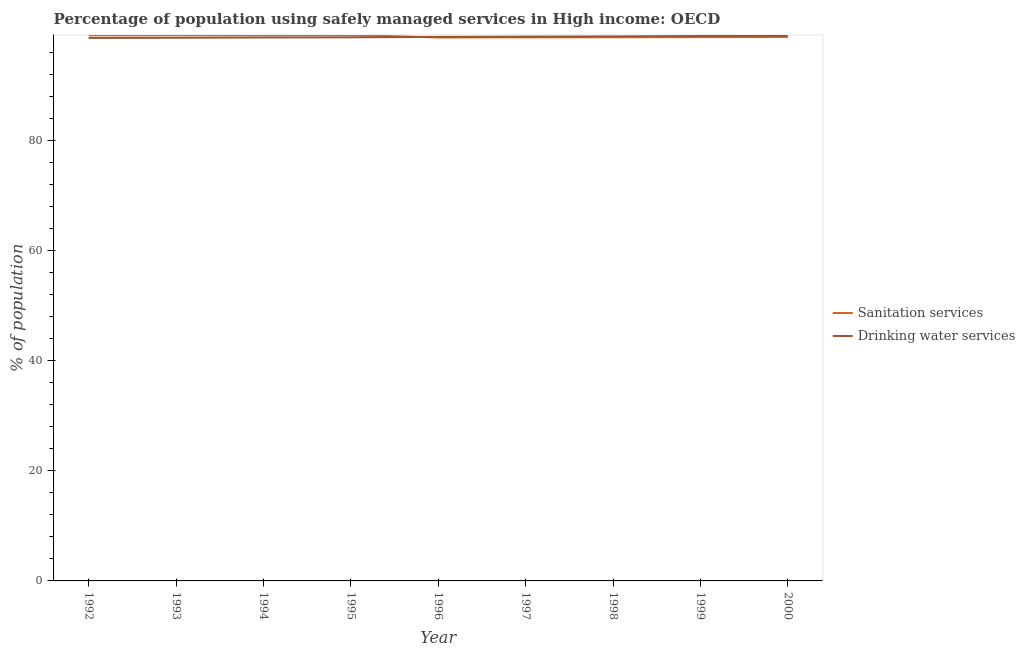How many different coloured lines are there?
Make the answer very short. 2. Is the number of lines equal to the number of legend labels?
Offer a terse response. Yes. What is the percentage of population who used sanitation services in 1993?
Offer a very short reply. 99.13. Across all years, what is the maximum percentage of population who used sanitation services?
Ensure brevity in your answer.  99.17. Across all years, what is the minimum percentage of population who used drinking water services?
Offer a very short reply. 98.64. In which year was the percentage of population who used sanitation services maximum?
Provide a succinct answer. 1995. In which year was the percentage of population who used drinking water services minimum?
Give a very brief answer. 1992. What is the total percentage of population who used sanitation services in the graph?
Keep it short and to the point. 890.37. What is the difference between the percentage of population who used sanitation services in 1994 and that in 2000?
Your answer should be compact. 0.34. What is the difference between the percentage of population who used drinking water services in 1999 and the percentage of population who used sanitation services in 1994?
Offer a terse response. -0.16. What is the average percentage of population who used drinking water services per year?
Provide a short and direct response. 98.82. In the year 1999, what is the difference between the percentage of population who used sanitation services and percentage of population who used drinking water services?
Ensure brevity in your answer.  -0.21. What is the ratio of the percentage of population who used sanitation services in 1998 to that in 1999?
Provide a short and direct response. 1. Is the percentage of population who used drinking water services in 1996 less than that in 1997?
Provide a short and direct response. Yes. What is the difference between the highest and the second highest percentage of population who used drinking water services?
Keep it short and to the point. 0.04. What is the difference between the highest and the lowest percentage of population who used drinking water services?
Give a very brief answer. 0.39. In how many years, is the percentage of population who used drinking water services greater than the average percentage of population who used drinking water services taken over all years?
Provide a short and direct response. 5. Are the values on the major ticks of Y-axis written in scientific E-notation?
Offer a terse response. No. Does the graph contain grids?
Give a very brief answer. No. Where does the legend appear in the graph?
Offer a very short reply. Center right. How many legend labels are there?
Offer a very short reply. 2. What is the title of the graph?
Your answer should be very brief. Percentage of population using safely managed services in High income: OECD. Does "Personal remittances" appear as one of the legend labels in the graph?
Provide a succinct answer. No. What is the label or title of the Y-axis?
Provide a short and direct response. % of population. What is the % of population of Sanitation services in 1992?
Offer a terse response. 99.11. What is the % of population in Drinking water services in 1992?
Offer a terse response. 98.64. What is the % of population of Sanitation services in 1993?
Offer a terse response. 99.13. What is the % of population of Drinking water services in 1993?
Your answer should be very brief. 98.67. What is the % of population in Sanitation services in 1994?
Provide a short and direct response. 99.15. What is the % of population of Drinking water services in 1994?
Your answer should be very brief. 98.72. What is the % of population of Sanitation services in 1995?
Keep it short and to the point. 99.17. What is the % of population in Drinking water services in 1995?
Your answer should be compact. 98.75. What is the % of population in Sanitation services in 1996?
Your answer should be very brief. 98.72. What is the % of population in Drinking water services in 1996?
Ensure brevity in your answer.  98.82. What is the % of population in Sanitation services in 1997?
Your response must be concise. 98.74. What is the % of population in Drinking water services in 1997?
Make the answer very short. 98.87. What is the % of population in Sanitation services in 1998?
Your answer should be compact. 98.76. What is the % of population in Drinking water services in 1998?
Your answer should be very brief. 98.91. What is the % of population in Sanitation services in 1999?
Offer a very short reply. 98.78. What is the % of population of Drinking water services in 1999?
Provide a short and direct response. 98.99. What is the % of population in Sanitation services in 2000?
Make the answer very short. 98.8. What is the % of population in Drinking water services in 2000?
Provide a succinct answer. 99.02. Across all years, what is the maximum % of population in Sanitation services?
Offer a terse response. 99.17. Across all years, what is the maximum % of population of Drinking water services?
Offer a very short reply. 99.02. Across all years, what is the minimum % of population of Sanitation services?
Provide a short and direct response. 98.72. Across all years, what is the minimum % of population in Drinking water services?
Ensure brevity in your answer.  98.64. What is the total % of population of Sanitation services in the graph?
Ensure brevity in your answer.  890.37. What is the total % of population of Drinking water services in the graph?
Keep it short and to the point. 889.4. What is the difference between the % of population of Sanitation services in 1992 and that in 1993?
Give a very brief answer. -0.02. What is the difference between the % of population in Drinking water services in 1992 and that in 1993?
Offer a terse response. -0.03. What is the difference between the % of population of Sanitation services in 1992 and that in 1994?
Give a very brief answer. -0.04. What is the difference between the % of population of Drinking water services in 1992 and that in 1994?
Offer a very short reply. -0.09. What is the difference between the % of population in Sanitation services in 1992 and that in 1995?
Offer a very short reply. -0.05. What is the difference between the % of population of Drinking water services in 1992 and that in 1995?
Make the answer very short. -0.11. What is the difference between the % of population of Sanitation services in 1992 and that in 1996?
Offer a very short reply. 0.39. What is the difference between the % of population of Drinking water services in 1992 and that in 1996?
Give a very brief answer. -0.19. What is the difference between the % of population of Sanitation services in 1992 and that in 1997?
Your answer should be very brief. 0.37. What is the difference between the % of population of Drinking water services in 1992 and that in 1997?
Give a very brief answer. -0.23. What is the difference between the % of population in Sanitation services in 1992 and that in 1998?
Offer a terse response. 0.35. What is the difference between the % of population in Drinking water services in 1992 and that in 1998?
Make the answer very short. -0.27. What is the difference between the % of population in Sanitation services in 1992 and that in 1999?
Provide a succinct answer. 0.34. What is the difference between the % of population in Drinking water services in 1992 and that in 1999?
Give a very brief answer. -0.35. What is the difference between the % of population of Sanitation services in 1992 and that in 2000?
Your response must be concise. 0.31. What is the difference between the % of population of Drinking water services in 1992 and that in 2000?
Keep it short and to the point. -0.39. What is the difference between the % of population in Sanitation services in 1993 and that in 1994?
Your answer should be very brief. -0.02. What is the difference between the % of population in Drinking water services in 1993 and that in 1994?
Keep it short and to the point. -0.06. What is the difference between the % of population in Sanitation services in 1993 and that in 1995?
Offer a terse response. -0.03. What is the difference between the % of population of Drinking water services in 1993 and that in 1995?
Keep it short and to the point. -0.08. What is the difference between the % of population in Sanitation services in 1993 and that in 1996?
Your answer should be very brief. 0.41. What is the difference between the % of population of Drinking water services in 1993 and that in 1996?
Your answer should be compact. -0.15. What is the difference between the % of population in Sanitation services in 1993 and that in 1997?
Ensure brevity in your answer.  0.39. What is the difference between the % of population in Drinking water services in 1993 and that in 1997?
Provide a succinct answer. -0.2. What is the difference between the % of population in Sanitation services in 1993 and that in 1998?
Provide a succinct answer. 0.37. What is the difference between the % of population in Drinking water services in 1993 and that in 1998?
Offer a terse response. -0.24. What is the difference between the % of population in Sanitation services in 1993 and that in 1999?
Your answer should be compact. 0.35. What is the difference between the % of population in Drinking water services in 1993 and that in 1999?
Give a very brief answer. -0.32. What is the difference between the % of population of Sanitation services in 1993 and that in 2000?
Provide a short and direct response. 0.33. What is the difference between the % of population in Drinking water services in 1993 and that in 2000?
Provide a short and direct response. -0.36. What is the difference between the % of population of Sanitation services in 1994 and that in 1995?
Your response must be concise. -0.02. What is the difference between the % of population of Drinking water services in 1994 and that in 1995?
Give a very brief answer. -0.03. What is the difference between the % of population of Sanitation services in 1994 and that in 1996?
Make the answer very short. 0.43. What is the difference between the % of population of Drinking water services in 1994 and that in 1996?
Ensure brevity in your answer.  -0.1. What is the difference between the % of population of Sanitation services in 1994 and that in 1997?
Ensure brevity in your answer.  0.41. What is the difference between the % of population of Drinking water services in 1994 and that in 1997?
Your response must be concise. -0.14. What is the difference between the % of population in Sanitation services in 1994 and that in 1998?
Offer a very short reply. 0.39. What is the difference between the % of population of Drinking water services in 1994 and that in 1998?
Provide a succinct answer. -0.19. What is the difference between the % of population of Sanitation services in 1994 and that in 1999?
Ensure brevity in your answer.  0.37. What is the difference between the % of population in Drinking water services in 1994 and that in 1999?
Make the answer very short. -0.26. What is the difference between the % of population in Sanitation services in 1994 and that in 2000?
Ensure brevity in your answer.  0.34. What is the difference between the % of population in Sanitation services in 1995 and that in 1996?
Your response must be concise. 0.44. What is the difference between the % of population of Drinking water services in 1995 and that in 1996?
Your answer should be compact. -0.07. What is the difference between the % of population in Sanitation services in 1995 and that in 1997?
Make the answer very short. 0.42. What is the difference between the % of population in Drinking water services in 1995 and that in 1997?
Give a very brief answer. -0.12. What is the difference between the % of population of Sanitation services in 1995 and that in 1998?
Offer a very short reply. 0.41. What is the difference between the % of population of Drinking water services in 1995 and that in 1998?
Your response must be concise. -0.16. What is the difference between the % of population of Sanitation services in 1995 and that in 1999?
Provide a succinct answer. 0.39. What is the difference between the % of population of Drinking water services in 1995 and that in 1999?
Your answer should be very brief. -0.24. What is the difference between the % of population of Sanitation services in 1995 and that in 2000?
Make the answer very short. 0.36. What is the difference between the % of population of Drinking water services in 1995 and that in 2000?
Your answer should be compact. -0.27. What is the difference between the % of population of Sanitation services in 1996 and that in 1997?
Offer a terse response. -0.02. What is the difference between the % of population of Drinking water services in 1996 and that in 1997?
Offer a terse response. -0.05. What is the difference between the % of population of Sanitation services in 1996 and that in 1998?
Keep it short and to the point. -0.04. What is the difference between the % of population in Drinking water services in 1996 and that in 1998?
Provide a succinct answer. -0.09. What is the difference between the % of population of Sanitation services in 1996 and that in 1999?
Ensure brevity in your answer.  -0.06. What is the difference between the % of population in Drinking water services in 1996 and that in 1999?
Your answer should be very brief. -0.16. What is the difference between the % of population of Sanitation services in 1996 and that in 2000?
Keep it short and to the point. -0.08. What is the difference between the % of population of Drinking water services in 1996 and that in 2000?
Provide a short and direct response. -0.2. What is the difference between the % of population in Sanitation services in 1997 and that in 1998?
Your answer should be very brief. -0.02. What is the difference between the % of population of Drinking water services in 1997 and that in 1998?
Your answer should be compact. -0.04. What is the difference between the % of population in Sanitation services in 1997 and that in 1999?
Give a very brief answer. -0.04. What is the difference between the % of population of Drinking water services in 1997 and that in 1999?
Provide a succinct answer. -0.12. What is the difference between the % of population of Sanitation services in 1997 and that in 2000?
Provide a succinct answer. -0.06. What is the difference between the % of population in Drinking water services in 1997 and that in 2000?
Give a very brief answer. -0.16. What is the difference between the % of population in Sanitation services in 1998 and that in 1999?
Provide a short and direct response. -0.02. What is the difference between the % of population in Drinking water services in 1998 and that in 1999?
Your response must be concise. -0.08. What is the difference between the % of population of Sanitation services in 1998 and that in 2000?
Offer a very short reply. -0.04. What is the difference between the % of population in Drinking water services in 1998 and that in 2000?
Your answer should be compact. -0.11. What is the difference between the % of population of Sanitation services in 1999 and that in 2000?
Give a very brief answer. -0.03. What is the difference between the % of population of Drinking water services in 1999 and that in 2000?
Make the answer very short. -0.04. What is the difference between the % of population in Sanitation services in 1992 and the % of population in Drinking water services in 1993?
Make the answer very short. 0.45. What is the difference between the % of population of Sanitation services in 1992 and the % of population of Drinking water services in 1994?
Offer a terse response. 0.39. What is the difference between the % of population of Sanitation services in 1992 and the % of population of Drinking water services in 1995?
Provide a succinct answer. 0.36. What is the difference between the % of population in Sanitation services in 1992 and the % of population in Drinking water services in 1996?
Offer a terse response. 0.29. What is the difference between the % of population in Sanitation services in 1992 and the % of population in Drinking water services in 1997?
Make the answer very short. 0.25. What is the difference between the % of population in Sanitation services in 1992 and the % of population in Drinking water services in 1998?
Offer a very short reply. 0.2. What is the difference between the % of population of Sanitation services in 1992 and the % of population of Drinking water services in 1999?
Make the answer very short. 0.13. What is the difference between the % of population of Sanitation services in 1992 and the % of population of Drinking water services in 2000?
Your answer should be very brief. 0.09. What is the difference between the % of population of Sanitation services in 1993 and the % of population of Drinking water services in 1994?
Your response must be concise. 0.41. What is the difference between the % of population in Sanitation services in 1993 and the % of population in Drinking water services in 1995?
Provide a succinct answer. 0.38. What is the difference between the % of population of Sanitation services in 1993 and the % of population of Drinking water services in 1996?
Your answer should be compact. 0.31. What is the difference between the % of population of Sanitation services in 1993 and the % of population of Drinking water services in 1997?
Keep it short and to the point. 0.26. What is the difference between the % of population in Sanitation services in 1993 and the % of population in Drinking water services in 1998?
Make the answer very short. 0.22. What is the difference between the % of population of Sanitation services in 1993 and the % of population of Drinking water services in 1999?
Your response must be concise. 0.15. What is the difference between the % of population in Sanitation services in 1993 and the % of population in Drinking water services in 2000?
Make the answer very short. 0.11. What is the difference between the % of population of Sanitation services in 1994 and the % of population of Drinking water services in 1995?
Keep it short and to the point. 0.4. What is the difference between the % of population in Sanitation services in 1994 and the % of population in Drinking water services in 1996?
Your answer should be compact. 0.33. What is the difference between the % of population in Sanitation services in 1994 and the % of population in Drinking water services in 1997?
Your response must be concise. 0.28. What is the difference between the % of population in Sanitation services in 1994 and the % of population in Drinking water services in 1998?
Provide a short and direct response. 0.24. What is the difference between the % of population of Sanitation services in 1994 and the % of population of Drinking water services in 1999?
Provide a short and direct response. 0.16. What is the difference between the % of population in Sanitation services in 1994 and the % of population in Drinking water services in 2000?
Your answer should be compact. 0.13. What is the difference between the % of population of Sanitation services in 1995 and the % of population of Drinking water services in 1996?
Provide a short and direct response. 0.34. What is the difference between the % of population in Sanitation services in 1995 and the % of population in Drinking water services in 1997?
Your response must be concise. 0.3. What is the difference between the % of population in Sanitation services in 1995 and the % of population in Drinking water services in 1998?
Make the answer very short. 0.26. What is the difference between the % of population in Sanitation services in 1995 and the % of population in Drinking water services in 1999?
Your answer should be very brief. 0.18. What is the difference between the % of population in Sanitation services in 1995 and the % of population in Drinking water services in 2000?
Your answer should be compact. 0.14. What is the difference between the % of population in Sanitation services in 1996 and the % of population in Drinking water services in 1997?
Give a very brief answer. -0.15. What is the difference between the % of population in Sanitation services in 1996 and the % of population in Drinking water services in 1998?
Provide a succinct answer. -0.19. What is the difference between the % of population of Sanitation services in 1996 and the % of population of Drinking water services in 1999?
Make the answer very short. -0.26. What is the difference between the % of population in Sanitation services in 1996 and the % of population in Drinking water services in 2000?
Offer a very short reply. -0.3. What is the difference between the % of population in Sanitation services in 1997 and the % of population in Drinking water services in 1998?
Ensure brevity in your answer.  -0.17. What is the difference between the % of population in Sanitation services in 1997 and the % of population in Drinking water services in 1999?
Give a very brief answer. -0.24. What is the difference between the % of population in Sanitation services in 1997 and the % of population in Drinking water services in 2000?
Provide a short and direct response. -0.28. What is the difference between the % of population in Sanitation services in 1998 and the % of population in Drinking water services in 1999?
Make the answer very short. -0.23. What is the difference between the % of population in Sanitation services in 1998 and the % of population in Drinking water services in 2000?
Give a very brief answer. -0.26. What is the difference between the % of population of Sanitation services in 1999 and the % of population of Drinking water services in 2000?
Ensure brevity in your answer.  -0.25. What is the average % of population in Sanitation services per year?
Ensure brevity in your answer.  98.93. What is the average % of population of Drinking water services per year?
Offer a terse response. 98.82. In the year 1992, what is the difference between the % of population in Sanitation services and % of population in Drinking water services?
Offer a very short reply. 0.48. In the year 1993, what is the difference between the % of population of Sanitation services and % of population of Drinking water services?
Your answer should be very brief. 0.46. In the year 1994, what is the difference between the % of population in Sanitation services and % of population in Drinking water services?
Provide a succinct answer. 0.43. In the year 1995, what is the difference between the % of population in Sanitation services and % of population in Drinking water services?
Provide a short and direct response. 0.42. In the year 1996, what is the difference between the % of population of Sanitation services and % of population of Drinking water services?
Provide a succinct answer. -0.1. In the year 1997, what is the difference between the % of population of Sanitation services and % of population of Drinking water services?
Offer a terse response. -0.13. In the year 1998, what is the difference between the % of population in Sanitation services and % of population in Drinking water services?
Give a very brief answer. -0.15. In the year 1999, what is the difference between the % of population of Sanitation services and % of population of Drinking water services?
Make the answer very short. -0.21. In the year 2000, what is the difference between the % of population of Sanitation services and % of population of Drinking water services?
Your answer should be compact. -0.22. What is the ratio of the % of population in Drinking water services in 1992 to that in 1993?
Provide a short and direct response. 1. What is the ratio of the % of population of Drinking water services in 1992 to that in 1996?
Your response must be concise. 1. What is the ratio of the % of population of Sanitation services in 1992 to that in 1997?
Ensure brevity in your answer.  1. What is the ratio of the % of population of Sanitation services in 1992 to that in 1998?
Provide a short and direct response. 1. What is the ratio of the % of population in Drinking water services in 1992 to that in 1998?
Keep it short and to the point. 1. What is the ratio of the % of population of Sanitation services in 1992 to that in 1999?
Your answer should be compact. 1. What is the ratio of the % of population of Sanitation services in 1992 to that in 2000?
Ensure brevity in your answer.  1. What is the ratio of the % of population of Drinking water services in 1992 to that in 2000?
Give a very brief answer. 1. What is the ratio of the % of population of Sanitation services in 1993 to that in 1995?
Offer a very short reply. 1. What is the ratio of the % of population of Sanitation services in 1993 to that in 1996?
Provide a short and direct response. 1. What is the ratio of the % of population in Drinking water services in 1993 to that in 1996?
Provide a succinct answer. 1. What is the ratio of the % of population in Sanitation services in 1993 to that in 1997?
Offer a very short reply. 1. What is the ratio of the % of population of Drinking water services in 1993 to that in 1999?
Make the answer very short. 1. What is the ratio of the % of population in Drinking water services in 1993 to that in 2000?
Your answer should be compact. 1. What is the ratio of the % of population of Sanitation services in 1994 to that in 1995?
Keep it short and to the point. 1. What is the ratio of the % of population of Drinking water services in 1994 to that in 1995?
Offer a terse response. 1. What is the ratio of the % of population in Drinking water services in 1994 to that in 1996?
Provide a short and direct response. 1. What is the ratio of the % of population of Sanitation services in 1994 to that in 1997?
Ensure brevity in your answer.  1. What is the ratio of the % of population in Drinking water services in 1994 to that in 1997?
Provide a succinct answer. 1. What is the ratio of the % of population of Sanitation services in 1994 to that in 1998?
Your answer should be very brief. 1. What is the ratio of the % of population in Sanitation services in 1994 to that in 1999?
Give a very brief answer. 1. What is the ratio of the % of population of Sanitation services in 1994 to that in 2000?
Provide a succinct answer. 1. What is the ratio of the % of population of Drinking water services in 1994 to that in 2000?
Give a very brief answer. 1. What is the ratio of the % of population in Sanitation services in 1995 to that in 1997?
Your response must be concise. 1. What is the ratio of the % of population of Drinking water services in 1995 to that in 1998?
Your answer should be very brief. 1. What is the ratio of the % of population of Drinking water services in 1995 to that in 1999?
Your response must be concise. 1. What is the ratio of the % of population of Sanitation services in 1995 to that in 2000?
Make the answer very short. 1. What is the ratio of the % of population in Sanitation services in 1996 to that in 1997?
Keep it short and to the point. 1. What is the ratio of the % of population of Drinking water services in 1996 to that in 1997?
Keep it short and to the point. 1. What is the ratio of the % of population of Drinking water services in 1996 to that in 1999?
Ensure brevity in your answer.  1. What is the ratio of the % of population of Drinking water services in 1997 to that in 1998?
Offer a terse response. 1. What is the ratio of the % of population of Sanitation services in 1997 to that in 2000?
Give a very brief answer. 1. What is the ratio of the % of population of Sanitation services in 1999 to that in 2000?
Your answer should be compact. 1. What is the difference between the highest and the second highest % of population of Sanitation services?
Make the answer very short. 0.02. What is the difference between the highest and the second highest % of population of Drinking water services?
Your answer should be compact. 0.04. What is the difference between the highest and the lowest % of population of Sanitation services?
Provide a succinct answer. 0.44. What is the difference between the highest and the lowest % of population of Drinking water services?
Make the answer very short. 0.39. 